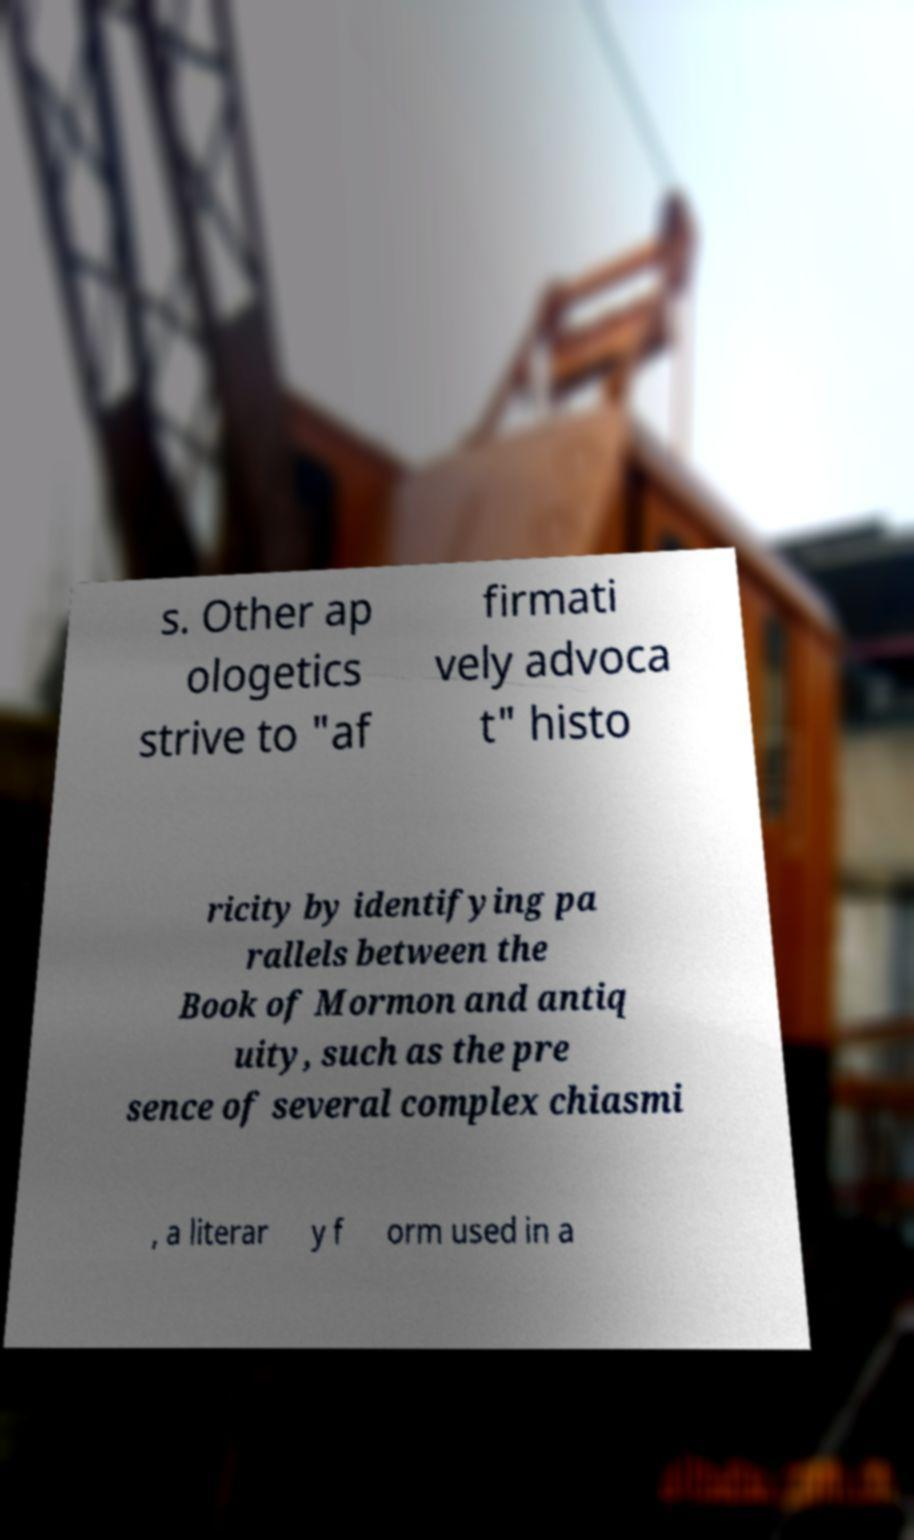There's text embedded in this image that I need extracted. Can you transcribe it verbatim? s. Other ap ologetics strive to "af firmati vely advoca t" histo ricity by identifying pa rallels between the Book of Mormon and antiq uity, such as the pre sence of several complex chiasmi , a literar y f orm used in a 